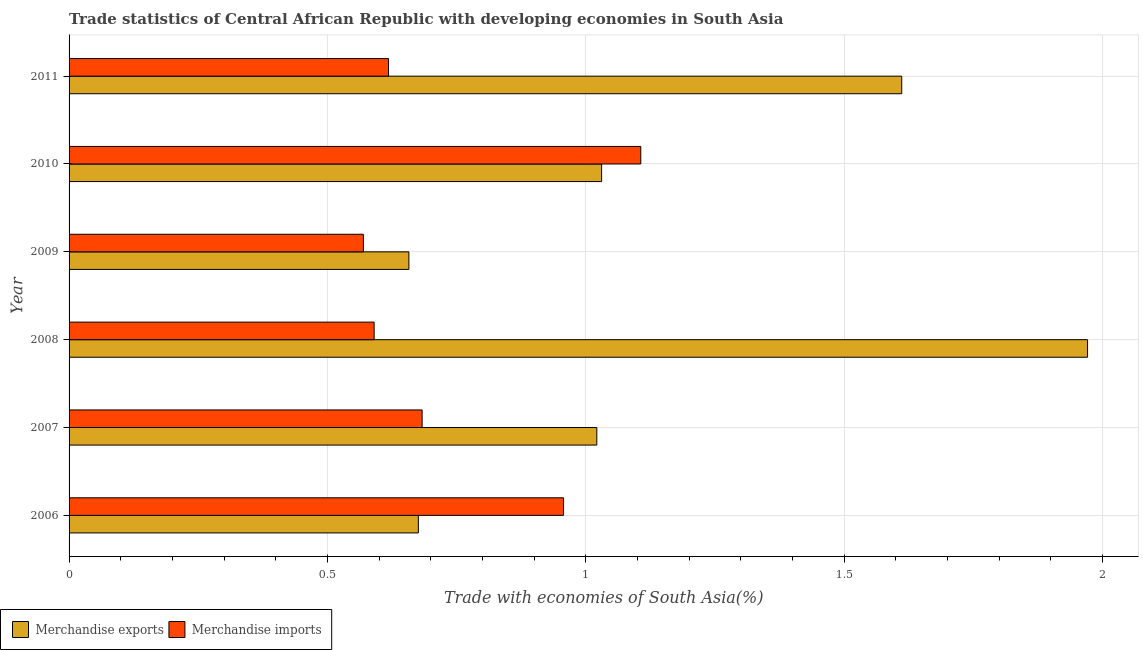How many different coloured bars are there?
Your answer should be very brief. 2. How many groups of bars are there?
Offer a terse response. 6. Are the number of bars per tick equal to the number of legend labels?
Ensure brevity in your answer.  Yes. Are the number of bars on each tick of the Y-axis equal?
Offer a very short reply. Yes. How many bars are there on the 3rd tick from the top?
Provide a short and direct response. 2. How many bars are there on the 2nd tick from the bottom?
Keep it short and to the point. 2. What is the merchandise imports in 2006?
Keep it short and to the point. 0.96. Across all years, what is the maximum merchandise exports?
Your answer should be very brief. 1.97. Across all years, what is the minimum merchandise imports?
Ensure brevity in your answer.  0.57. In which year was the merchandise imports maximum?
Provide a short and direct response. 2010. What is the total merchandise exports in the graph?
Your answer should be very brief. 6.97. What is the difference between the merchandise imports in 2010 and that in 2011?
Ensure brevity in your answer.  0.49. What is the difference between the merchandise exports in 2006 and the merchandise imports in 2011?
Offer a very short reply. 0.06. What is the average merchandise exports per year?
Provide a short and direct response. 1.16. In the year 2006, what is the difference between the merchandise imports and merchandise exports?
Your answer should be compact. 0.28. What is the ratio of the merchandise imports in 2008 to that in 2010?
Your answer should be very brief. 0.53. Is the merchandise imports in 2008 less than that in 2010?
Keep it short and to the point. Yes. Is the difference between the merchandise imports in 2008 and 2009 greater than the difference between the merchandise exports in 2008 and 2009?
Provide a short and direct response. No. What is the difference between the highest and the second highest merchandise imports?
Ensure brevity in your answer.  0.15. What is the difference between the highest and the lowest merchandise exports?
Offer a terse response. 1.31. What is the difference between two consecutive major ticks on the X-axis?
Ensure brevity in your answer.  0.5. Does the graph contain any zero values?
Keep it short and to the point. No. Where does the legend appear in the graph?
Provide a succinct answer. Bottom left. How many legend labels are there?
Give a very brief answer. 2. What is the title of the graph?
Provide a short and direct response. Trade statistics of Central African Republic with developing economies in South Asia. Does "Mobile cellular" appear as one of the legend labels in the graph?
Offer a terse response. No. What is the label or title of the X-axis?
Offer a terse response. Trade with economies of South Asia(%). What is the label or title of the Y-axis?
Your response must be concise. Year. What is the Trade with economies of South Asia(%) in Merchandise exports in 2006?
Give a very brief answer. 0.68. What is the Trade with economies of South Asia(%) in Merchandise imports in 2006?
Provide a short and direct response. 0.96. What is the Trade with economies of South Asia(%) of Merchandise exports in 2007?
Give a very brief answer. 1.02. What is the Trade with economies of South Asia(%) of Merchandise imports in 2007?
Provide a succinct answer. 0.68. What is the Trade with economies of South Asia(%) in Merchandise exports in 2008?
Offer a terse response. 1.97. What is the Trade with economies of South Asia(%) in Merchandise imports in 2008?
Keep it short and to the point. 0.59. What is the Trade with economies of South Asia(%) of Merchandise exports in 2009?
Your response must be concise. 0.66. What is the Trade with economies of South Asia(%) of Merchandise imports in 2009?
Offer a very short reply. 0.57. What is the Trade with economies of South Asia(%) in Merchandise exports in 2010?
Offer a very short reply. 1.03. What is the Trade with economies of South Asia(%) in Merchandise imports in 2010?
Ensure brevity in your answer.  1.11. What is the Trade with economies of South Asia(%) of Merchandise exports in 2011?
Your answer should be very brief. 1.61. What is the Trade with economies of South Asia(%) in Merchandise imports in 2011?
Offer a very short reply. 0.62. Across all years, what is the maximum Trade with economies of South Asia(%) in Merchandise exports?
Give a very brief answer. 1.97. Across all years, what is the maximum Trade with economies of South Asia(%) of Merchandise imports?
Your answer should be very brief. 1.11. Across all years, what is the minimum Trade with economies of South Asia(%) in Merchandise exports?
Provide a succinct answer. 0.66. Across all years, what is the minimum Trade with economies of South Asia(%) of Merchandise imports?
Make the answer very short. 0.57. What is the total Trade with economies of South Asia(%) of Merchandise exports in the graph?
Your answer should be very brief. 6.97. What is the total Trade with economies of South Asia(%) in Merchandise imports in the graph?
Give a very brief answer. 4.52. What is the difference between the Trade with economies of South Asia(%) in Merchandise exports in 2006 and that in 2007?
Provide a short and direct response. -0.35. What is the difference between the Trade with economies of South Asia(%) of Merchandise imports in 2006 and that in 2007?
Provide a succinct answer. 0.27. What is the difference between the Trade with economies of South Asia(%) of Merchandise exports in 2006 and that in 2008?
Provide a succinct answer. -1.3. What is the difference between the Trade with economies of South Asia(%) of Merchandise imports in 2006 and that in 2008?
Make the answer very short. 0.37. What is the difference between the Trade with economies of South Asia(%) of Merchandise exports in 2006 and that in 2009?
Offer a very short reply. 0.02. What is the difference between the Trade with economies of South Asia(%) in Merchandise imports in 2006 and that in 2009?
Offer a terse response. 0.39. What is the difference between the Trade with economies of South Asia(%) in Merchandise exports in 2006 and that in 2010?
Give a very brief answer. -0.35. What is the difference between the Trade with economies of South Asia(%) in Merchandise imports in 2006 and that in 2010?
Provide a short and direct response. -0.15. What is the difference between the Trade with economies of South Asia(%) of Merchandise exports in 2006 and that in 2011?
Offer a very short reply. -0.94. What is the difference between the Trade with economies of South Asia(%) of Merchandise imports in 2006 and that in 2011?
Provide a short and direct response. 0.34. What is the difference between the Trade with economies of South Asia(%) in Merchandise exports in 2007 and that in 2008?
Your answer should be compact. -0.95. What is the difference between the Trade with economies of South Asia(%) of Merchandise imports in 2007 and that in 2008?
Provide a succinct answer. 0.09. What is the difference between the Trade with economies of South Asia(%) of Merchandise exports in 2007 and that in 2009?
Ensure brevity in your answer.  0.36. What is the difference between the Trade with economies of South Asia(%) of Merchandise imports in 2007 and that in 2009?
Offer a terse response. 0.11. What is the difference between the Trade with economies of South Asia(%) in Merchandise exports in 2007 and that in 2010?
Make the answer very short. -0.01. What is the difference between the Trade with economies of South Asia(%) in Merchandise imports in 2007 and that in 2010?
Offer a terse response. -0.42. What is the difference between the Trade with economies of South Asia(%) of Merchandise exports in 2007 and that in 2011?
Provide a succinct answer. -0.59. What is the difference between the Trade with economies of South Asia(%) in Merchandise imports in 2007 and that in 2011?
Your response must be concise. 0.07. What is the difference between the Trade with economies of South Asia(%) of Merchandise exports in 2008 and that in 2009?
Ensure brevity in your answer.  1.31. What is the difference between the Trade with economies of South Asia(%) in Merchandise imports in 2008 and that in 2009?
Provide a succinct answer. 0.02. What is the difference between the Trade with economies of South Asia(%) in Merchandise exports in 2008 and that in 2010?
Ensure brevity in your answer.  0.94. What is the difference between the Trade with economies of South Asia(%) of Merchandise imports in 2008 and that in 2010?
Offer a terse response. -0.52. What is the difference between the Trade with economies of South Asia(%) in Merchandise exports in 2008 and that in 2011?
Your answer should be very brief. 0.36. What is the difference between the Trade with economies of South Asia(%) in Merchandise imports in 2008 and that in 2011?
Your answer should be compact. -0.03. What is the difference between the Trade with economies of South Asia(%) in Merchandise exports in 2009 and that in 2010?
Offer a very short reply. -0.37. What is the difference between the Trade with economies of South Asia(%) in Merchandise imports in 2009 and that in 2010?
Give a very brief answer. -0.54. What is the difference between the Trade with economies of South Asia(%) of Merchandise exports in 2009 and that in 2011?
Provide a succinct answer. -0.95. What is the difference between the Trade with economies of South Asia(%) in Merchandise imports in 2009 and that in 2011?
Provide a short and direct response. -0.05. What is the difference between the Trade with economies of South Asia(%) of Merchandise exports in 2010 and that in 2011?
Your response must be concise. -0.58. What is the difference between the Trade with economies of South Asia(%) in Merchandise imports in 2010 and that in 2011?
Offer a very short reply. 0.49. What is the difference between the Trade with economies of South Asia(%) of Merchandise exports in 2006 and the Trade with economies of South Asia(%) of Merchandise imports in 2007?
Offer a very short reply. -0.01. What is the difference between the Trade with economies of South Asia(%) in Merchandise exports in 2006 and the Trade with economies of South Asia(%) in Merchandise imports in 2008?
Your response must be concise. 0.09. What is the difference between the Trade with economies of South Asia(%) of Merchandise exports in 2006 and the Trade with economies of South Asia(%) of Merchandise imports in 2009?
Keep it short and to the point. 0.11. What is the difference between the Trade with economies of South Asia(%) of Merchandise exports in 2006 and the Trade with economies of South Asia(%) of Merchandise imports in 2010?
Provide a short and direct response. -0.43. What is the difference between the Trade with economies of South Asia(%) in Merchandise exports in 2006 and the Trade with economies of South Asia(%) in Merchandise imports in 2011?
Make the answer very short. 0.06. What is the difference between the Trade with economies of South Asia(%) of Merchandise exports in 2007 and the Trade with economies of South Asia(%) of Merchandise imports in 2008?
Offer a terse response. 0.43. What is the difference between the Trade with economies of South Asia(%) in Merchandise exports in 2007 and the Trade with economies of South Asia(%) in Merchandise imports in 2009?
Your answer should be very brief. 0.45. What is the difference between the Trade with economies of South Asia(%) of Merchandise exports in 2007 and the Trade with economies of South Asia(%) of Merchandise imports in 2010?
Keep it short and to the point. -0.09. What is the difference between the Trade with economies of South Asia(%) of Merchandise exports in 2007 and the Trade with economies of South Asia(%) of Merchandise imports in 2011?
Provide a short and direct response. 0.4. What is the difference between the Trade with economies of South Asia(%) in Merchandise exports in 2008 and the Trade with economies of South Asia(%) in Merchandise imports in 2009?
Your answer should be compact. 1.4. What is the difference between the Trade with economies of South Asia(%) in Merchandise exports in 2008 and the Trade with economies of South Asia(%) in Merchandise imports in 2010?
Provide a succinct answer. 0.86. What is the difference between the Trade with economies of South Asia(%) in Merchandise exports in 2008 and the Trade with economies of South Asia(%) in Merchandise imports in 2011?
Offer a very short reply. 1.35. What is the difference between the Trade with economies of South Asia(%) in Merchandise exports in 2009 and the Trade with economies of South Asia(%) in Merchandise imports in 2010?
Give a very brief answer. -0.45. What is the difference between the Trade with economies of South Asia(%) of Merchandise exports in 2009 and the Trade with economies of South Asia(%) of Merchandise imports in 2011?
Keep it short and to the point. 0.04. What is the difference between the Trade with economies of South Asia(%) in Merchandise exports in 2010 and the Trade with economies of South Asia(%) in Merchandise imports in 2011?
Keep it short and to the point. 0.41. What is the average Trade with economies of South Asia(%) of Merchandise exports per year?
Keep it short and to the point. 1.16. What is the average Trade with economies of South Asia(%) in Merchandise imports per year?
Ensure brevity in your answer.  0.75. In the year 2006, what is the difference between the Trade with economies of South Asia(%) in Merchandise exports and Trade with economies of South Asia(%) in Merchandise imports?
Make the answer very short. -0.28. In the year 2007, what is the difference between the Trade with economies of South Asia(%) of Merchandise exports and Trade with economies of South Asia(%) of Merchandise imports?
Your answer should be compact. 0.34. In the year 2008, what is the difference between the Trade with economies of South Asia(%) of Merchandise exports and Trade with economies of South Asia(%) of Merchandise imports?
Ensure brevity in your answer.  1.38. In the year 2009, what is the difference between the Trade with economies of South Asia(%) of Merchandise exports and Trade with economies of South Asia(%) of Merchandise imports?
Make the answer very short. 0.09. In the year 2010, what is the difference between the Trade with economies of South Asia(%) in Merchandise exports and Trade with economies of South Asia(%) in Merchandise imports?
Provide a succinct answer. -0.08. In the year 2011, what is the difference between the Trade with economies of South Asia(%) in Merchandise exports and Trade with economies of South Asia(%) in Merchandise imports?
Your response must be concise. 0.99. What is the ratio of the Trade with economies of South Asia(%) in Merchandise exports in 2006 to that in 2007?
Your answer should be compact. 0.66. What is the ratio of the Trade with economies of South Asia(%) of Merchandise imports in 2006 to that in 2007?
Your response must be concise. 1.4. What is the ratio of the Trade with economies of South Asia(%) in Merchandise exports in 2006 to that in 2008?
Give a very brief answer. 0.34. What is the ratio of the Trade with economies of South Asia(%) of Merchandise imports in 2006 to that in 2008?
Ensure brevity in your answer.  1.62. What is the ratio of the Trade with economies of South Asia(%) in Merchandise exports in 2006 to that in 2009?
Offer a very short reply. 1.03. What is the ratio of the Trade with economies of South Asia(%) in Merchandise imports in 2006 to that in 2009?
Offer a terse response. 1.68. What is the ratio of the Trade with economies of South Asia(%) of Merchandise exports in 2006 to that in 2010?
Your response must be concise. 0.66. What is the ratio of the Trade with economies of South Asia(%) of Merchandise imports in 2006 to that in 2010?
Your response must be concise. 0.86. What is the ratio of the Trade with economies of South Asia(%) in Merchandise exports in 2006 to that in 2011?
Ensure brevity in your answer.  0.42. What is the ratio of the Trade with economies of South Asia(%) in Merchandise imports in 2006 to that in 2011?
Give a very brief answer. 1.55. What is the ratio of the Trade with economies of South Asia(%) of Merchandise exports in 2007 to that in 2008?
Your response must be concise. 0.52. What is the ratio of the Trade with economies of South Asia(%) in Merchandise imports in 2007 to that in 2008?
Offer a terse response. 1.16. What is the ratio of the Trade with economies of South Asia(%) in Merchandise exports in 2007 to that in 2009?
Make the answer very short. 1.55. What is the ratio of the Trade with economies of South Asia(%) in Merchandise imports in 2007 to that in 2009?
Offer a very short reply. 1.2. What is the ratio of the Trade with economies of South Asia(%) in Merchandise exports in 2007 to that in 2010?
Offer a very short reply. 0.99. What is the ratio of the Trade with economies of South Asia(%) of Merchandise imports in 2007 to that in 2010?
Your answer should be very brief. 0.62. What is the ratio of the Trade with economies of South Asia(%) of Merchandise exports in 2007 to that in 2011?
Offer a terse response. 0.63. What is the ratio of the Trade with economies of South Asia(%) of Merchandise imports in 2007 to that in 2011?
Offer a very short reply. 1.11. What is the ratio of the Trade with economies of South Asia(%) in Merchandise exports in 2008 to that in 2009?
Your answer should be very brief. 3. What is the ratio of the Trade with economies of South Asia(%) in Merchandise imports in 2008 to that in 2009?
Your response must be concise. 1.04. What is the ratio of the Trade with economies of South Asia(%) in Merchandise exports in 2008 to that in 2010?
Provide a succinct answer. 1.91. What is the ratio of the Trade with economies of South Asia(%) of Merchandise imports in 2008 to that in 2010?
Offer a very short reply. 0.53. What is the ratio of the Trade with economies of South Asia(%) in Merchandise exports in 2008 to that in 2011?
Provide a succinct answer. 1.22. What is the ratio of the Trade with economies of South Asia(%) in Merchandise imports in 2008 to that in 2011?
Ensure brevity in your answer.  0.95. What is the ratio of the Trade with economies of South Asia(%) of Merchandise exports in 2009 to that in 2010?
Keep it short and to the point. 0.64. What is the ratio of the Trade with economies of South Asia(%) in Merchandise imports in 2009 to that in 2010?
Your answer should be very brief. 0.51. What is the ratio of the Trade with economies of South Asia(%) of Merchandise exports in 2009 to that in 2011?
Your answer should be very brief. 0.41. What is the ratio of the Trade with economies of South Asia(%) of Merchandise imports in 2009 to that in 2011?
Ensure brevity in your answer.  0.92. What is the ratio of the Trade with economies of South Asia(%) of Merchandise exports in 2010 to that in 2011?
Your answer should be compact. 0.64. What is the ratio of the Trade with economies of South Asia(%) in Merchandise imports in 2010 to that in 2011?
Your answer should be very brief. 1.79. What is the difference between the highest and the second highest Trade with economies of South Asia(%) in Merchandise exports?
Offer a very short reply. 0.36. What is the difference between the highest and the second highest Trade with economies of South Asia(%) of Merchandise imports?
Provide a short and direct response. 0.15. What is the difference between the highest and the lowest Trade with economies of South Asia(%) in Merchandise exports?
Make the answer very short. 1.31. What is the difference between the highest and the lowest Trade with economies of South Asia(%) of Merchandise imports?
Offer a very short reply. 0.54. 